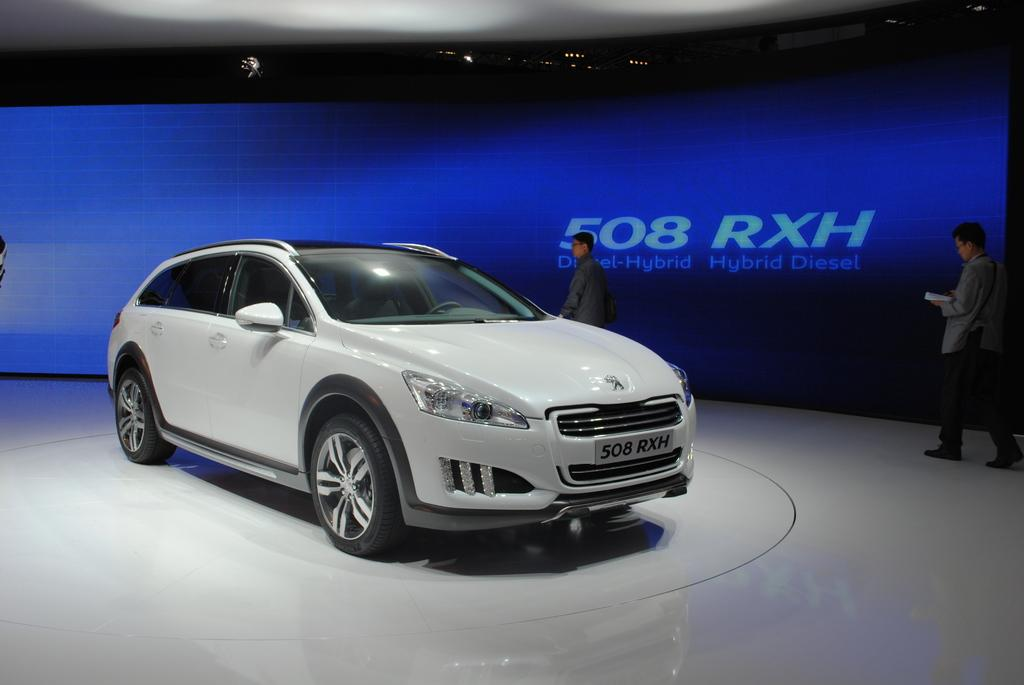What type of vehicle is in the image? There is a white car in the image. Where is the car located? The car is on the floor. What can be seen on the right side of the car? There are two persons walking on the right side of the car. What is present behind the car? There is a banner with text behind the car. What type of ornament is hanging from the tail of the car in the image? There is no ornament hanging from the tail of the car in the image, as the car does not have a tail. 